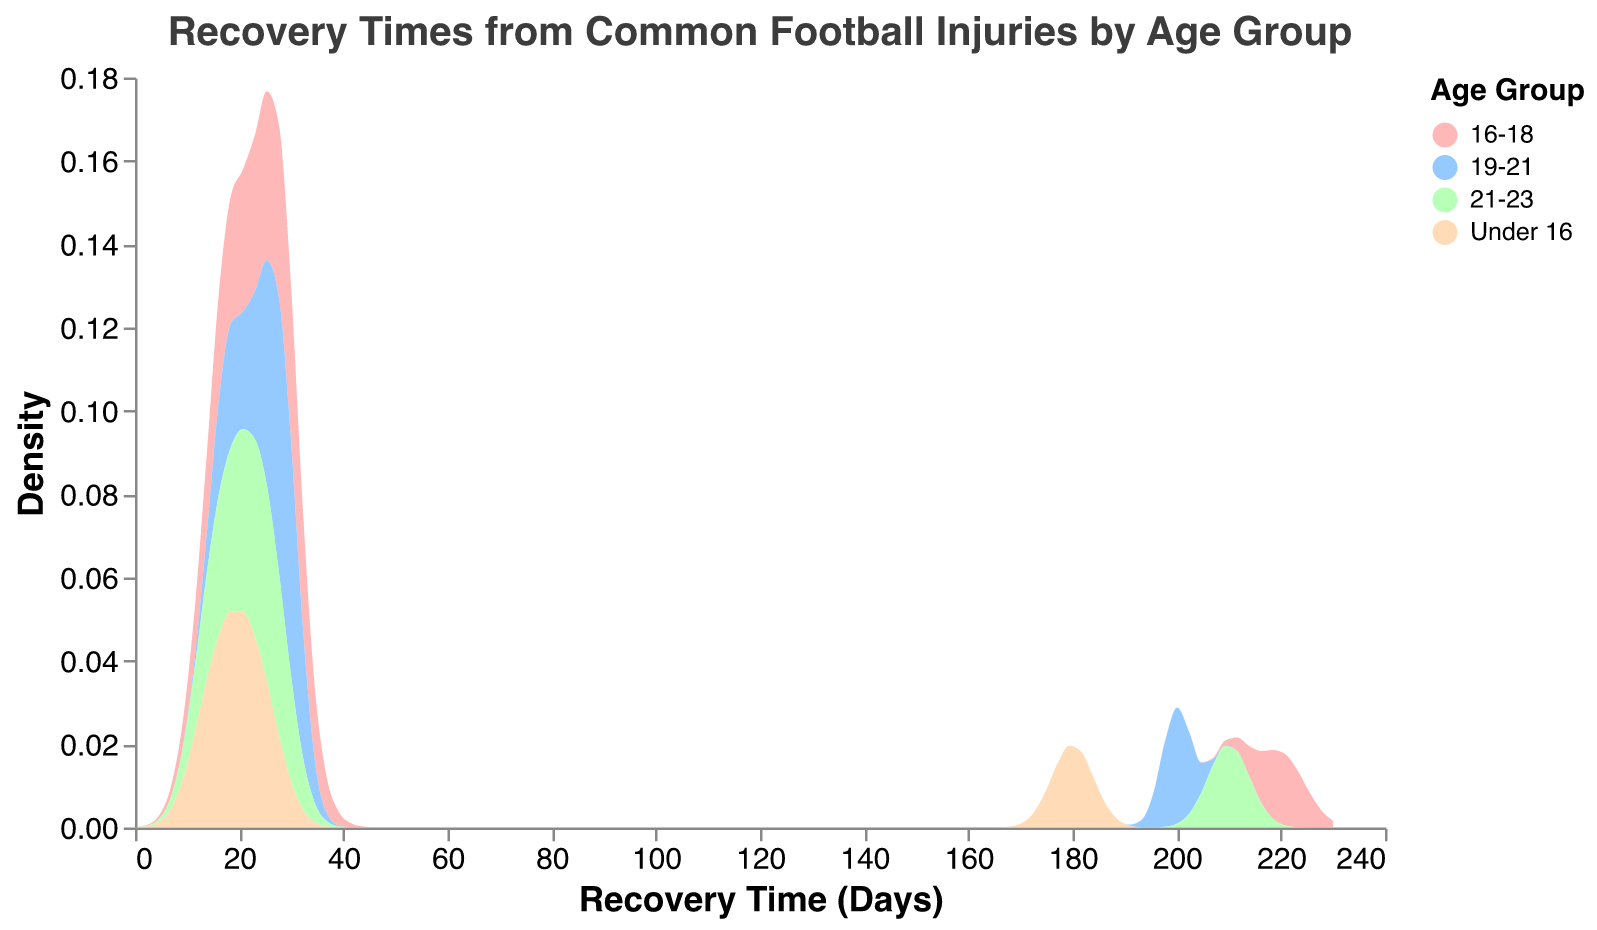What is the title of the figure? The title of a figure is usually located at the top and in this figure, it states the overview or main focus of the visualization.
Answer: Recovery Times from Common Football Injuries by Age Group What is the color used to represent the 21-23 age group? To identify this, look at the color legend in the figure. You will see that the color associated with each age group is specified there.
Answer: Light orange What age group has the highest density for recovery times around 200 days? By examining the density plot, check which age group's density area peaks around the 200-day mark on the x-axis.
Answer: 19-21 Which age group has the smallest recovery time range? Look at the spread along the x-axis for each age group. The age group with the smallest spread in recovery times has the smallest range.
Answer: Under 16 In which age group are ankle sprains and hamstring strains recovery times closest together? Check the density plot segments for each age group and note where the areas for ankle sprains and hamstring strains are closest in terms of x-axis values.
Answer: 21-23 What is the general trend in recovery times for ACL tears as the age group increases? Look at how the density areas for ACL tears shift along the x-axis as you go from "Under 16" towards "21-23."
Answer: Increasing Which age group has the most diverse (widespread) recovery times? Compare the width of the density areas across the x-axis for each age group. The age group with the widest area has the most diverse recovery times.
Answer: 16-18 Between the 16-18 and 19-21 age groups, which one generally has shorter recovery times for concussions? Locate the density areas for concussions for both age groups and see which one is positioned more to the left (shorter recovery times) on the x-axis.
Answer: 16-18 